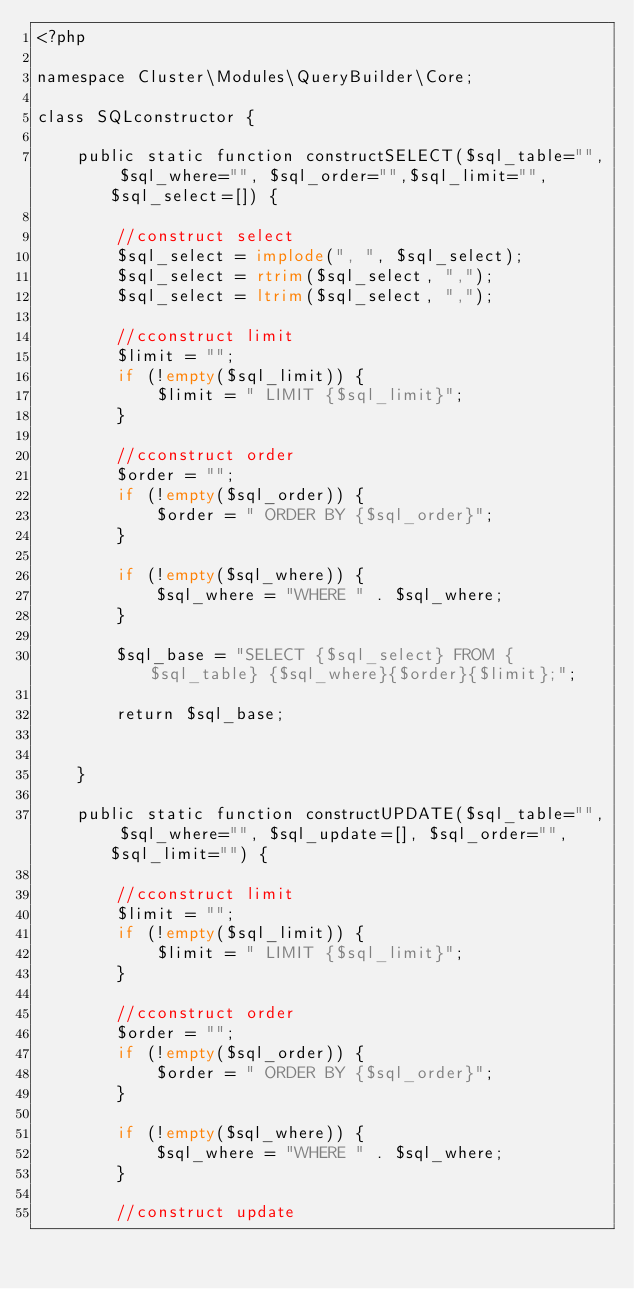Convert code to text. <code><loc_0><loc_0><loc_500><loc_500><_PHP_><?php 

namespace Cluster\Modules\QueryBuilder\Core;

class SQLconstructor {

	public static function constructSELECT($sql_table="", $sql_where="", $sql_order="",$sql_limit="", $sql_select=[]) {

		//construct select
		$sql_select = implode(", ", $sql_select);
		$sql_select = rtrim($sql_select, ",");
		$sql_select = ltrim($sql_select, ",");
		
		//cconstruct limit 
		$limit = "";
		if (!empty($sql_limit)) {
			$limit = " LIMIT {$sql_limit}";
		}

		//cconstruct order 
		$order = "";
		if (!empty($sql_order)) {
			$order = " ORDER BY {$sql_order}";
		}

		if (!empty($sql_where)) {
			$sql_where = "WHERE " . $sql_where;
		}

		$sql_base = "SELECT {$sql_select} FROM {$sql_table} {$sql_where}{$order}{$limit};";

		return $sql_base;


	}

	public static function constructUPDATE($sql_table="", $sql_where="", $sql_update=[], $sql_order="",$sql_limit="") {

		//cconstruct limit 
		$limit = "";
		if (!empty($sql_limit)) {
			$limit = " LIMIT {$sql_limit}";
		}

		//cconstruct order 
		$order = "";
		if (!empty($sql_order)) {
			$order = " ORDER BY {$sql_order}";
		}

		if (!empty($sql_where)) {
			$sql_where = "WHERE " . $sql_where;
		}

		//construct update</code> 